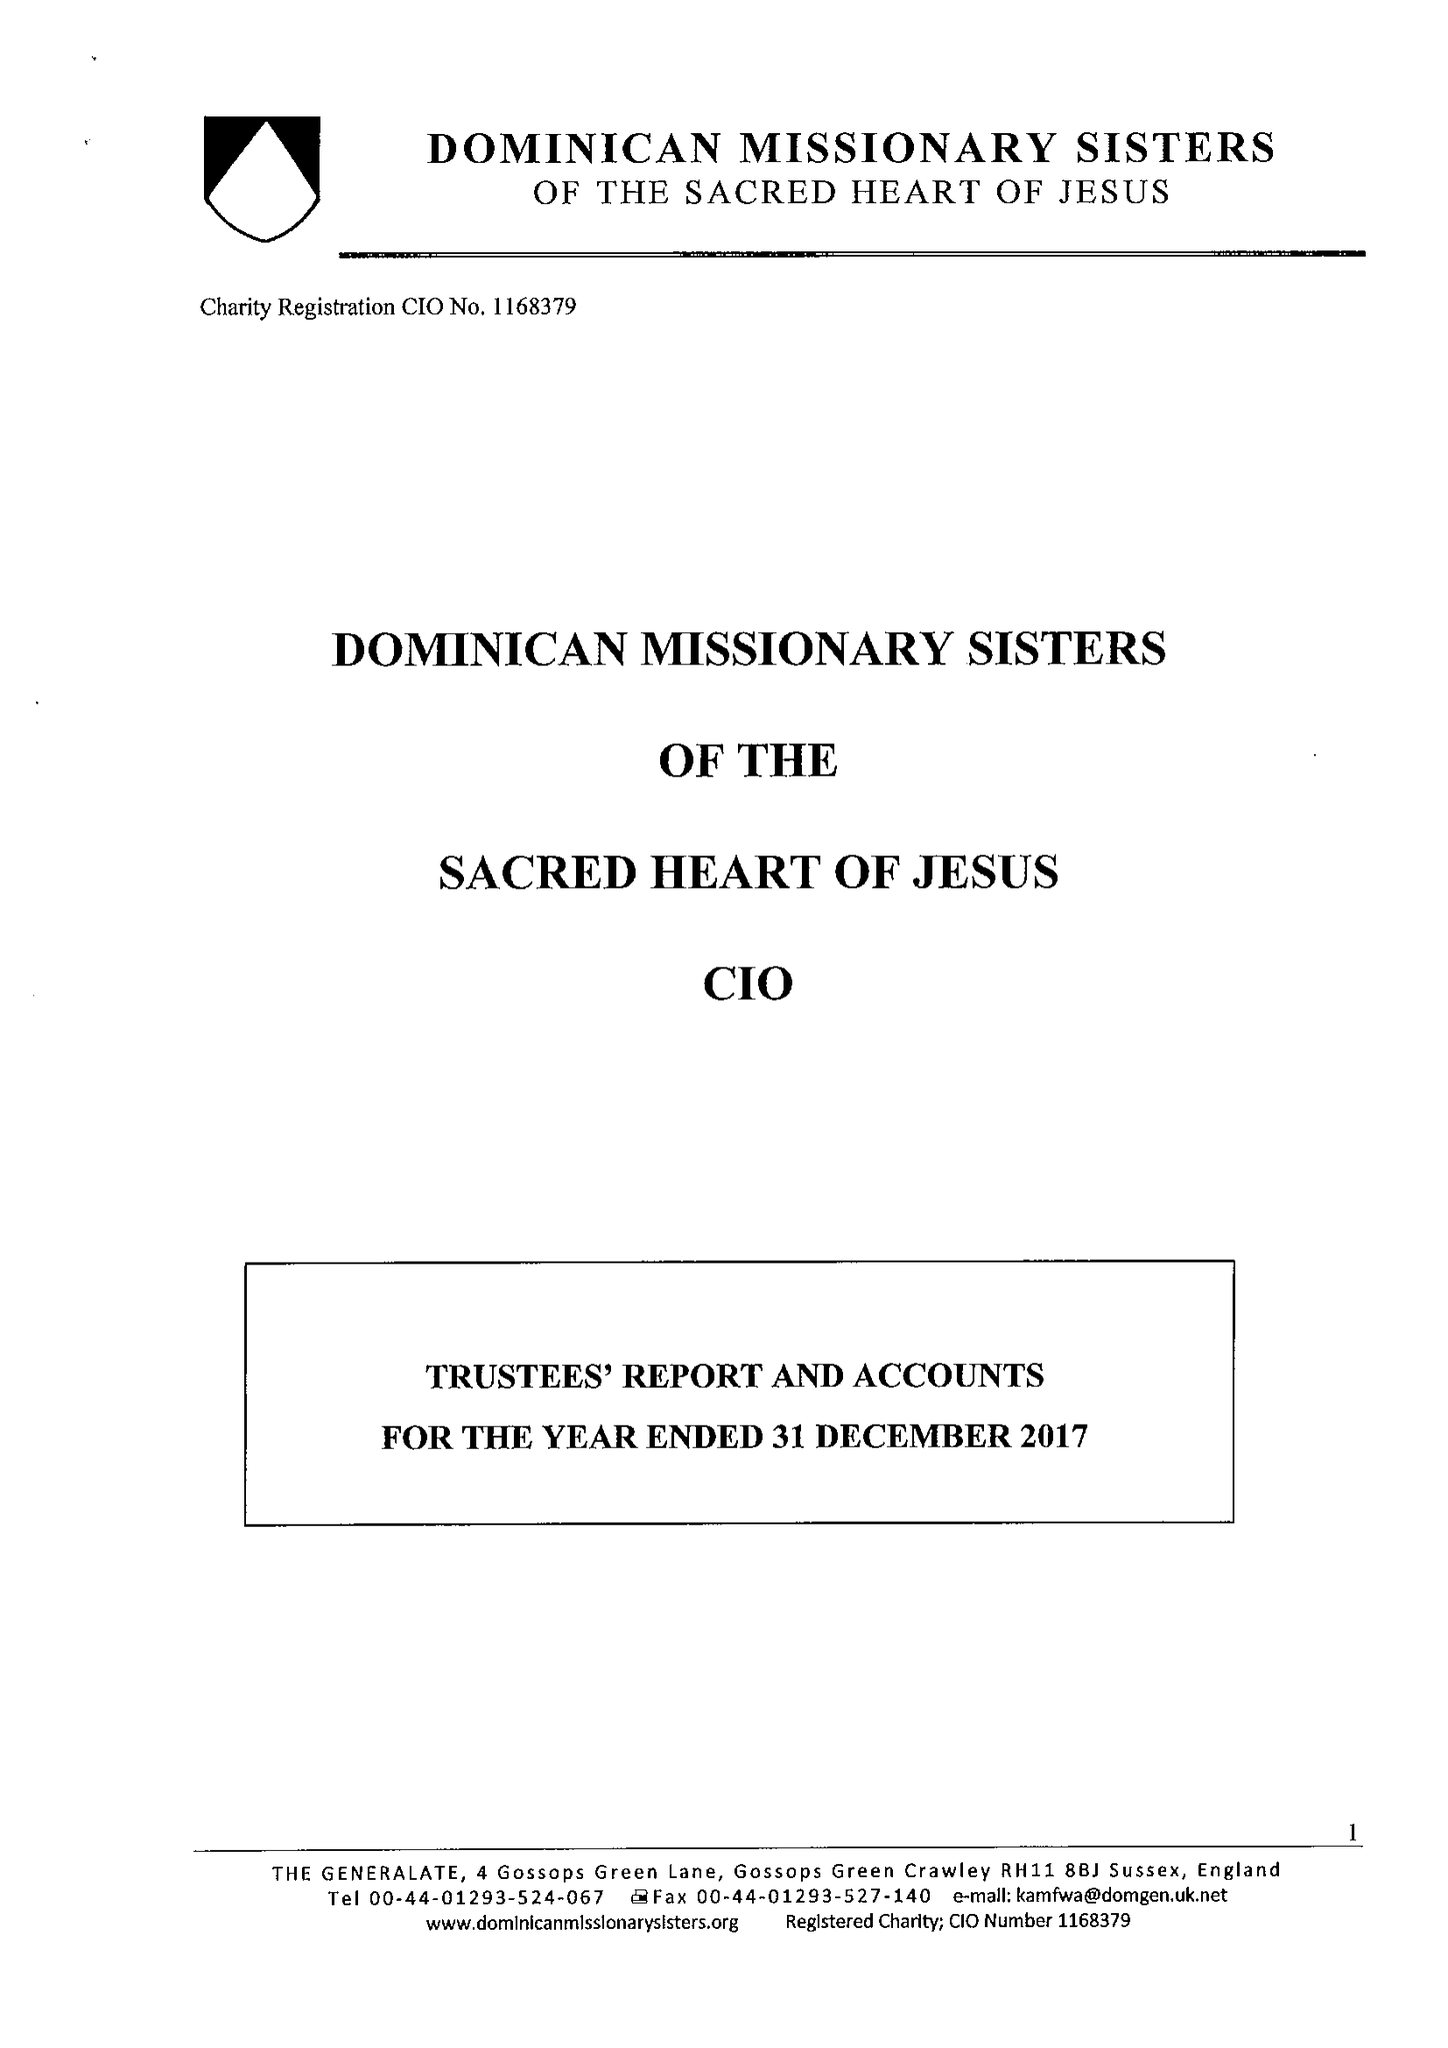What is the value for the charity_name?
Answer the question using a single word or phrase. Dominican Missionary Sisters Of The Sacred Heart Of Jesus CIO 